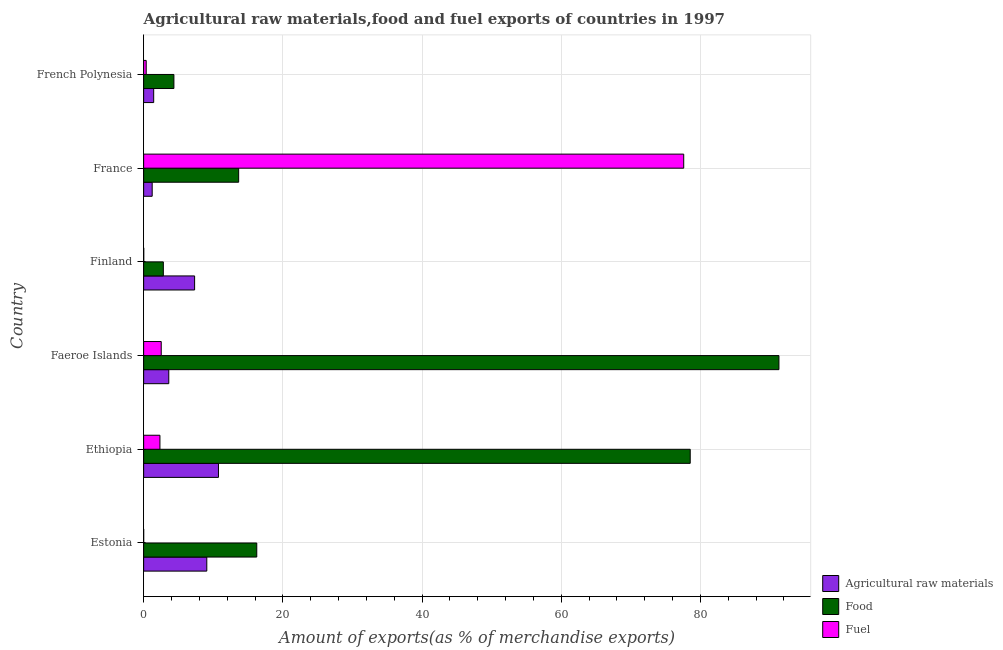How many groups of bars are there?
Provide a succinct answer. 6. Are the number of bars per tick equal to the number of legend labels?
Your answer should be compact. Yes. How many bars are there on the 1st tick from the top?
Ensure brevity in your answer.  3. What is the label of the 1st group of bars from the top?
Your answer should be compact. French Polynesia. What is the percentage of raw materials exports in Estonia?
Keep it short and to the point. 9.07. Across all countries, what is the maximum percentage of fuel exports?
Your response must be concise. 77.6. Across all countries, what is the minimum percentage of food exports?
Give a very brief answer. 2.83. In which country was the percentage of food exports maximum?
Make the answer very short. Faeroe Islands. In which country was the percentage of fuel exports minimum?
Provide a succinct answer. Estonia. What is the total percentage of food exports in the graph?
Keep it short and to the point. 206.9. What is the difference between the percentage of raw materials exports in Estonia and that in Faeroe Islands?
Your answer should be compact. 5.46. What is the difference between the percentage of raw materials exports in Ethiopia and the percentage of food exports in French Polynesia?
Keep it short and to the point. 6.4. What is the average percentage of fuel exports per country?
Your response must be concise. 13.81. What is the difference between the percentage of fuel exports and percentage of food exports in Faeroe Islands?
Offer a very short reply. -88.75. Is the percentage of raw materials exports in Faeroe Islands less than that in Finland?
Keep it short and to the point. Yes. What is the difference between the highest and the second highest percentage of fuel exports?
Offer a terse response. 75.08. What is the difference between the highest and the lowest percentage of raw materials exports?
Ensure brevity in your answer.  9.52. In how many countries, is the percentage of fuel exports greater than the average percentage of fuel exports taken over all countries?
Provide a succinct answer. 1. What does the 3rd bar from the top in France represents?
Your response must be concise. Agricultural raw materials. What does the 3rd bar from the bottom in Ethiopia represents?
Give a very brief answer. Fuel. How many bars are there?
Offer a very short reply. 18. Are all the bars in the graph horizontal?
Provide a succinct answer. Yes. Are the values on the major ticks of X-axis written in scientific E-notation?
Make the answer very short. No. Does the graph contain any zero values?
Keep it short and to the point. No. Where does the legend appear in the graph?
Provide a short and direct response. Bottom right. How many legend labels are there?
Your answer should be very brief. 3. How are the legend labels stacked?
Offer a very short reply. Vertical. What is the title of the graph?
Offer a terse response. Agricultural raw materials,food and fuel exports of countries in 1997. What is the label or title of the X-axis?
Your answer should be very brief. Amount of exports(as % of merchandise exports). What is the label or title of the Y-axis?
Provide a short and direct response. Country. What is the Amount of exports(as % of merchandise exports) of Agricultural raw materials in Estonia?
Provide a succinct answer. 9.07. What is the Amount of exports(as % of merchandise exports) of Food in Estonia?
Give a very brief answer. 16.25. What is the Amount of exports(as % of merchandise exports) in Fuel in Estonia?
Your answer should be very brief. 0. What is the Amount of exports(as % of merchandise exports) in Agricultural raw materials in Ethiopia?
Your answer should be very brief. 10.75. What is the Amount of exports(as % of merchandise exports) of Food in Ethiopia?
Make the answer very short. 78.54. What is the Amount of exports(as % of merchandise exports) of Fuel in Ethiopia?
Ensure brevity in your answer.  2.34. What is the Amount of exports(as % of merchandise exports) of Agricultural raw materials in Faeroe Islands?
Make the answer very short. 3.61. What is the Amount of exports(as % of merchandise exports) in Food in Faeroe Islands?
Keep it short and to the point. 91.28. What is the Amount of exports(as % of merchandise exports) of Fuel in Faeroe Islands?
Your answer should be very brief. 2.53. What is the Amount of exports(as % of merchandise exports) in Agricultural raw materials in Finland?
Provide a succinct answer. 7.32. What is the Amount of exports(as % of merchandise exports) in Food in Finland?
Your answer should be very brief. 2.83. What is the Amount of exports(as % of merchandise exports) in Fuel in Finland?
Give a very brief answer. 0.01. What is the Amount of exports(as % of merchandise exports) of Agricultural raw materials in France?
Offer a very short reply. 1.23. What is the Amount of exports(as % of merchandise exports) of Food in France?
Offer a terse response. 13.65. What is the Amount of exports(as % of merchandise exports) in Fuel in France?
Your answer should be compact. 77.6. What is the Amount of exports(as % of merchandise exports) of Agricultural raw materials in French Polynesia?
Provide a succinct answer. 1.44. What is the Amount of exports(as % of merchandise exports) of Food in French Polynesia?
Give a very brief answer. 4.35. What is the Amount of exports(as % of merchandise exports) of Fuel in French Polynesia?
Ensure brevity in your answer.  0.37. Across all countries, what is the maximum Amount of exports(as % of merchandise exports) of Agricultural raw materials?
Your response must be concise. 10.75. Across all countries, what is the maximum Amount of exports(as % of merchandise exports) in Food?
Your answer should be compact. 91.28. Across all countries, what is the maximum Amount of exports(as % of merchandise exports) in Fuel?
Provide a succinct answer. 77.6. Across all countries, what is the minimum Amount of exports(as % of merchandise exports) in Agricultural raw materials?
Give a very brief answer. 1.23. Across all countries, what is the minimum Amount of exports(as % of merchandise exports) of Food?
Offer a terse response. 2.83. Across all countries, what is the minimum Amount of exports(as % of merchandise exports) in Fuel?
Provide a succinct answer. 0. What is the total Amount of exports(as % of merchandise exports) of Agricultural raw materials in the graph?
Make the answer very short. 33.43. What is the total Amount of exports(as % of merchandise exports) in Food in the graph?
Your response must be concise. 206.9. What is the total Amount of exports(as % of merchandise exports) in Fuel in the graph?
Your response must be concise. 82.85. What is the difference between the Amount of exports(as % of merchandise exports) of Agricultural raw materials in Estonia and that in Ethiopia?
Your answer should be very brief. -1.68. What is the difference between the Amount of exports(as % of merchandise exports) in Food in Estonia and that in Ethiopia?
Provide a succinct answer. -62.28. What is the difference between the Amount of exports(as % of merchandise exports) in Fuel in Estonia and that in Ethiopia?
Give a very brief answer. -2.34. What is the difference between the Amount of exports(as % of merchandise exports) in Agricultural raw materials in Estonia and that in Faeroe Islands?
Offer a terse response. 5.46. What is the difference between the Amount of exports(as % of merchandise exports) in Food in Estonia and that in Faeroe Islands?
Keep it short and to the point. -75.03. What is the difference between the Amount of exports(as % of merchandise exports) in Fuel in Estonia and that in Faeroe Islands?
Your answer should be very brief. -2.53. What is the difference between the Amount of exports(as % of merchandise exports) in Agricultural raw materials in Estonia and that in Finland?
Provide a short and direct response. 1.75. What is the difference between the Amount of exports(as % of merchandise exports) of Food in Estonia and that in Finland?
Provide a succinct answer. 13.42. What is the difference between the Amount of exports(as % of merchandise exports) of Fuel in Estonia and that in Finland?
Make the answer very short. -0.01. What is the difference between the Amount of exports(as % of merchandise exports) of Agricultural raw materials in Estonia and that in France?
Your answer should be compact. 7.85. What is the difference between the Amount of exports(as % of merchandise exports) of Food in Estonia and that in France?
Make the answer very short. 2.6. What is the difference between the Amount of exports(as % of merchandise exports) in Fuel in Estonia and that in France?
Make the answer very short. -77.6. What is the difference between the Amount of exports(as % of merchandise exports) in Agricultural raw materials in Estonia and that in French Polynesia?
Your response must be concise. 7.63. What is the difference between the Amount of exports(as % of merchandise exports) in Food in Estonia and that in French Polynesia?
Keep it short and to the point. 11.91. What is the difference between the Amount of exports(as % of merchandise exports) in Fuel in Estonia and that in French Polynesia?
Your response must be concise. -0.37. What is the difference between the Amount of exports(as % of merchandise exports) in Agricultural raw materials in Ethiopia and that in Faeroe Islands?
Offer a terse response. 7.14. What is the difference between the Amount of exports(as % of merchandise exports) of Food in Ethiopia and that in Faeroe Islands?
Give a very brief answer. -12.75. What is the difference between the Amount of exports(as % of merchandise exports) in Fuel in Ethiopia and that in Faeroe Islands?
Make the answer very short. -0.19. What is the difference between the Amount of exports(as % of merchandise exports) in Agricultural raw materials in Ethiopia and that in Finland?
Make the answer very short. 3.43. What is the difference between the Amount of exports(as % of merchandise exports) in Food in Ethiopia and that in Finland?
Your answer should be very brief. 75.71. What is the difference between the Amount of exports(as % of merchandise exports) of Fuel in Ethiopia and that in Finland?
Your answer should be very brief. 2.33. What is the difference between the Amount of exports(as % of merchandise exports) of Agricultural raw materials in Ethiopia and that in France?
Offer a terse response. 9.52. What is the difference between the Amount of exports(as % of merchandise exports) of Food in Ethiopia and that in France?
Provide a short and direct response. 64.89. What is the difference between the Amount of exports(as % of merchandise exports) in Fuel in Ethiopia and that in France?
Your response must be concise. -75.26. What is the difference between the Amount of exports(as % of merchandise exports) of Agricultural raw materials in Ethiopia and that in French Polynesia?
Your answer should be very brief. 9.31. What is the difference between the Amount of exports(as % of merchandise exports) in Food in Ethiopia and that in French Polynesia?
Offer a very short reply. 74.19. What is the difference between the Amount of exports(as % of merchandise exports) of Fuel in Ethiopia and that in French Polynesia?
Make the answer very short. 1.97. What is the difference between the Amount of exports(as % of merchandise exports) in Agricultural raw materials in Faeroe Islands and that in Finland?
Your answer should be very brief. -3.71. What is the difference between the Amount of exports(as % of merchandise exports) of Food in Faeroe Islands and that in Finland?
Make the answer very short. 88.45. What is the difference between the Amount of exports(as % of merchandise exports) in Fuel in Faeroe Islands and that in Finland?
Make the answer very short. 2.51. What is the difference between the Amount of exports(as % of merchandise exports) of Agricultural raw materials in Faeroe Islands and that in France?
Your answer should be very brief. 2.39. What is the difference between the Amount of exports(as % of merchandise exports) of Food in Faeroe Islands and that in France?
Your answer should be very brief. 77.63. What is the difference between the Amount of exports(as % of merchandise exports) in Fuel in Faeroe Islands and that in France?
Make the answer very short. -75.07. What is the difference between the Amount of exports(as % of merchandise exports) in Agricultural raw materials in Faeroe Islands and that in French Polynesia?
Your answer should be very brief. 2.17. What is the difference between the Amount of exports(as % of merchandise exports) in Food in Faeroe Islands and that in French Polynesia?
Offer a very short reply. 86.93. What is the difference between the Amount of exports(as % of merchandise exports) in Fuel in Faeroe Islands and that in French Polynesia?
Keep it short and to the point. 2.16. What is the difference between the Amount of exports(as % of merchandise exports) in Agricultural raw materials in Finland and that in France?
Ensure brevity in your answer.  6.1. What is the difference between the Amount of exports(as % of merchandise exports) in Food in Finland and that in France?
Offer a very short reply. -10.82. What is the difference between the Amount of exports(as % of merchandise exports) in Fuel in Finland and that in France?
Offer a very short reply. -77.59. What is the difference between the Amount of exports(as % of merchandise exports) in Agricultural raw materials in Finland and that in French Polynesia?
Your response must be concise. 5.88. What is the difference between the Amount of exports(as % of merchandise exports) of Food in Finland and that in French Polynesia?
Your answer should be very brief. -1.52. What is the difference between the Amount of exports(as % of merchandise exports) in Fuel in Finland and that in French Polynesia?
Offer a very short reply. -0.35. What is the difference between the Amount of exports(as % of merchandise exports) of Agricultural raw materials in France and that in French Polynesia?
Ensure brevity in your answer.  -0.22. What is the difference between the Amount of exports(as % of merchandise exports) in Food in France and that in French Polynesia?
Make the answer very short. 9.3. What is the difference between the Amount of exports(as % of merchandise exports) in Fuel in France and that in French Polynesia?
Provide a succinct answer. 77.23. What is the difference between the Amount of exports(as % of merchandise exports) of Agricultural raw materials in Estonia and the Amount of exports(as % of merchandise exports) of Food in Ethiopia?
Provide a succinct answer. -69.46. What is the difference between the Amount of exports(as % of merchandise exports) of Agricultural raw materials in Estonia and the Amount of exports(as % of merchandise exports) of Fuel in Ethiopia?
Make the answer very short. 6.73. What is the difference between the Amount of exports(as % of merchandise exports) in Food in Estonia and the Amount of exports(as % of merchandise exports) in Fuel in Ethiopia?
Offer a terse response. 13.91. What is the difference between the Amount of exports(as % of merchandise exports) of Agricultural raw materials in Estonia and the Amount of exports(as % of merchandise exports) of Food in Faeroe Islands?
Your response must be concise. -82.21. What is the difference between the Amount of exports(as % of merchandise exports) of Agricultural raw materials in Estonia and the Amount of exports(as % of merchandise exports) of Fuel in Faeroe Islands?
Offer a very short reply. 6.55. What is the difference between the Amount of exports(as % of merchandise exports) of Food in Estonia and the Amount of exports(as % of merchandise exports) of Fuel in Faeroe Islands?
Keep it short and to the point. 13.73. What is the difference between the Amount of exports(as % of merchandise exports) of Agricultural raw materials in Estonia and the Amount of exports(as % of merchandise exports) of Food in Finland?
Your answer should be very brief. 6.24. What is the difference between the Amount of exports(as % of merchandise exports) in Agricultural raw materials in Estonia and the Amount of exports(as % of merchandise exports) in Fuel in Finland?
Provide a succinct answer. 9.06. What is the difference between the Amount of exports(as % of merchandise exports) in Food in Estonia and the Amount of exports(as % of merchandise exports) in Fuel in Finland?
Ensure brevity in your answer.  16.24. What is the difference between the Amount of exports(as % of merchandise exports) in Agricultural raw materials in Estonia and the Amount of exports(as % of merchandise exports) in Food in France?
Offer a terse response. -4.58. What is the difference between the Amount of exports(as % of merchandise exports) of Agricultural raw materials in Estonia and the Amount of exports(as % of merchandise exports) of Fuel in France?
Provide a succinct answer. -68.53. What is the difference between the Amount of exports(as % of merchandise exports) in Food in Estonia and the Amount of exports(as % of merchandise exports) in Fuel in France?
Give a very brief answer. -61.35. What is the difference between the Amount of exports(as % of merchandise exports) in Agricultural raw materials in Estonia and the Amount of exports(as % of merchandise exports) in Food in French Polynesia?
Your answer should be very brief. 4.72. What is the difference between the Amount of exports(as % of merchandise exports) in Agricultural raw materials in Estonia and the Amount of exports(as % of merchandise exports) in Fuel in French Polynesia?
Provide a succinct answer. 8.71. What is the difference between the Amount of exports(as % of merchandise exports) in Food in Estonia and the Amount of exports(as % of merchandise exports) in Fuel in French Polynesia?
Your response must be concise. 15.89. What is the difference between the Amount of exports(as % of merchandise exports) in Agricultural raw materials in Ethiopia and the Amount of exports(as % of merchandise exports) in Food in Faeroe Islands?
Ensure brevity in your answer.  -80.53. What is the difference between the Amount of exports(as % of merchandise exports) of Agricultural raw materials in Ethiopia and the Amount of exports(as % of merchandise exports) of Fuel in Faeroe Islands?
Provide a succinct answer. 8.22. What is the difference between the Amount of exports(as % of merchandise exports) of Food in Ethiopia and the Amount of exports(as % of merchandise exports) of Fuel in Faeroe Islands?
Your answer should be compact. 76.01. What is the difference between the Amount of exports(as % of merchandise exports) in Agricultural raw materials in Ethiopia and the Amount of exports(as % of merchandise exports) in Food in Finland?
Ensure brevity in your answer.  7.92. What is the difference between the Amount of exports(as % of merchandise exports) in Agricultural raw materials in Ethiopia and the Amount of exports(as % of merchandise exports) in Fuel in Finland?
Keep it short and to the point. 10.74. What is the difference between the Amount of exports(as % of merchandise exports) in Food in Ethiopia and the Amount of exports(as % of merchandise exports) in Fuel in Finland?
Keep it short and to the point. 78.52. What is the difference between the Amount of exports(as % of merchandise exports) of Agricultural raw materials in Ethiopia and the Amount of exports(as % of merchandise exports) of Food in France?
Your answer should be compact. -2.9. What is the difference between the Amount of exports(as % of merchandise exports) in Agricultural raw materials in Ethiopia and the Amount of exports(as % of merchandise exports) in Fuel in France?
Your answer should be very brief. -66.85. What is the difference between the Amount of exports(as % of merchandise exports) of Food in Ethiopia and the Amount of exports(as % of merchandise exports) of Fuel in France?
Your response must be concise. 0.93. What is the difference between the Amount of exports(as % of merchandise exports) in Agricultural raw materials in Ethiopia and the Amount of exports(as % of merchandise exports) in Food in French Polynesia?
Give a very brief answer. 6.4. What is the difference between the Amount of exports(as % of merchandise exports) of Agricultural raw materials in Ethiopia and the Amount of exports(as % of merchandise exports) of Fuel in French Polynesia?
Keep it short and to the point. 10.38. What is the difference between the Amount of exports(as % of merchandise exports) in Food in Ethiopia and the Amount of exports(as % of merchandise exports) in Fuel in French Polynesia?
Offer a very short reply. 78.17. What is the difference between the Amount of exports(as % of merchandise exports) in Agricultural raw materials in Faeroe Islands and the Amount of exports(as % of merchandise exports) in Food in Finland?
Offer a very short reply. 0.78. What is the difference between the Amount of exports(as % of merchandise exports) in Agricultural raw materials in Faeroe Islands and the Amount of exports(as % of merchandise exports) in Fuel in Finland?
Ensure brevity in your answer.  3.6. What is the difference between the Amount of exports(as % of merchandise exports) of Food in Faeroe Islands and the Amount of exports(as % of merchandise exports) of Fuel in Finland?
Your answer should be compact. 91.27. What is the difference between the Amount of exports(as % of merchandise exports) of Agricultural raw materials in Faeroe Islands and the Amount of exports(as % of merchandise exports) of Food in France?
Offer a very short reply. -10.04. What is the difference between the Amount of exports(as % of merchandise exports) in Agricultural raw materials in Faeroe Islands and the Amount of exports(as % of merchandise exports) in Fuel in France?
Keep it short and to the point. -73.99. What is the difference between the Amount of exports(as % of merchandise exports) in Food in Faeroe Islands and the Amount of exports(as % of merchandise exports) in Fuel in France?
Offer a terse response. 13.68. What is the difference between the Amount of exports(as % of merchandise exports) of Agricultural raw materials in Faeroe Islands and the Amount of exports(as % of merchandise exports) of Food in French Polynesia?
Offer a very short reply. -0.74. What is the difference between the Amount of exports(as % of merchandise exports) of Agricultural raw materials in Faeroe Islands and the Amount of exports(as % of merchandise exports) of Fuel in French Polynesia?
Keep it short and to the point. 3.24. What is the difference between the Amount of exports(as % of merchandise exports) of Food in Faeroe Islands and the Amount of exports(as % of merchandise exports) of Fuel in French Polynesia?
Offer a very short reply. 90.92. What is the difference between the Amount of exports(as % of merchandise exports) of Agricultural raw materials in Finland and the Amount of exports(as % of merchandise exports) of Food in France?
Provide a succinct answer. -6.33. What is the difference between the Amount of exports(as % of merchandise exports) of Agricultural raw materials in Finland and the Amount of exports(as % of merchandise exports) of Fuel in France?
Provide a succinct answer. -70.28. What is the difference between the Amount of exports(as % of merchandise exports) in Food in Finland and the Amount of exports(as % of merchandise exports) in Fuel in France?
Provide a short and direct response. -74.77. What is the difference between the Amount of exports(as % of merchandise exports) of Agricultural raw materials in Finland and the Amount of exports(as % of merchandise exports) of Food in French Polynesia?
Offer a very short reply. 2.97. What is the difference between the Amount of exports(as % of merchandise exports) of Agricultural raw materials in Finland and the Amount of exports(as % of merchandise exports) of Fuel in French Polynesia?
Provide a short and direct response. 6.96. What is the difference between the Amount of exports(as % of merchandise exports) in Food in Finland and the Amount of exports(as % of merchandise exports) in Fuel in French Polynesia?
Your response must be concise. 2.46. What is the difference between the Amount of exports(as % of merchandise exports) in Agricultural raw materials in France and the Amount of exports(as % of merchandise exports) in Food in French Polynesia?
Make the answer very short. -3.12. What is the difference between the Amount of exports(as % of merchandise exports) of Agricultural raw materials in France and the Amount of exports(as % of merchandise exports) of Fuel in French Polynesia?
Your response must be concise. 0.86. What is the difference between the Amount of exports(as % of merchandise exports) in Food in France and the Amount of exports(as % of merchandise exports) in Fuel in French Polynesia?
Give a very brief answer. 13.28. What is the average Amount of exports(as % of merchandise exports) of Agricultural raw materials per country?
Ensure brevity in your answer.  5.57. What is the average Amount of exports(as % of merchandise exports) in Food per country?
Give a very brief answer. 34.48. What is the average Amount of exports(as % of merchandise exports) of Fuel per country?
Provide a short and direct response. 13.81. What is the difference between the Amount of exports(as % of merchandise exports) in Agricultural raw materials and Amount of exports(as % of merchandise exports) in Food in Estonia?
Provide a short and direct response. -7.18. What is the difference between the Amount of exports(as % of merchandise exports) in Agricultural raw materials and Amount of exports(as % of merchandise exports) in Fuel in Estonia?
Provide a short and direct response. 9.07. What is the difference between the Amount of exports(as % of merchandise exports) in Food and Amount of exports(as % of merchandise exports) in Fuel in Estonia?
Provide a short and direct response. 16.25. What is the difference between the Amount of exports(as % of merchandise exports) of Agricultural raw materials and Amount of exports(as % of merchandise exports) of Food in Ethiopia?
Ensure brevity in your answer.  -67.78. What is the difference between the Amount of exports(as % of merchandise exports) of Agricultural raw materials and Amount of exports(as % of merchandise exports) of Fuel in Ethiopia?
Give a very brief answer. 8.41. What is the difference between the Amount of exports(as % of merchandise exports) of Food and Amount of exports(as % of merchandise exports) of Fuel in Ethiopia?
Make the answer very short. 76.2. What is the difference between the Amount of exports(as % of merchandise exports) in Agricultural raw materials and Amount of exports(as % of merchandise exports) in Food in Faeroe Islands?
Keep it short and to the point. -87.67. What is the difference between the Amount of exports(as % of merchandise exports) in Agricultural raw materials and Amount of exports(as % of merchandise exports) in Fuel in Faeroe Islands?
Keep it short and to the point. 1.08. What is the difference between the Amount of exports(as % of merchandise exports) of Food and Amount of exports(as % of merchandise exports) of Fuel in Faeroe Islands?
Make the answer very short. 88.76. What is the difference between the Amount of exports(as % of merchandise exports) of Agricultural raw materials and Amount of exports(as % of merchandise exports) of Food in Finland?
Your answer should be compact. 4.49. What is the difference between the Amount of exports(as % of merchandise exports) of Agricultural raw materials and Amount of exports(as % of merchandise exports) of Fuel in Finland?
Your answer should be compact. 7.31. What is the difference between the Amount of exports(as % of merchandise exports) in Food and Amount of exports(as % of merchandise exports) in Fuel in Finland?
Offer a very short reply. 2.82. What is the difference between the Amount of exports(as % of merchandise exports) of Agricultural raw materials and Amount of exports(as % of merchandise exports) of Food in France?
Make the answer very short. -12.42. What is the difference between the Amount of exports(as % of merchandise exports) in Agricultural raw materials and Amount of exports(as % of merchandise exports) in Fuel in France?
Offer a terse response. -76.38. What is the difference between the Amount of exports(as % of merchandise exports) of Food and Amount of exports(as % of merchandise exports) of Fuel in France?
Your answer should be compact. -63.95. What is the difference between the Amount of exports(as % of merchandise exports) of Agricultural raw materials and Amount of exports(as % of merchandise exports) of Food in French Polynesia?
Ensure brevity in your answer.  -2.91. What is the difference between the Amount of exports(as % of merchandise exports) in Agricultural raw materials and Amount of exports(as % of merchandise exports) in Fuel in French Polynesia?
Give a very brief answer. 1.07. What is the difference between the Amount of exports(as % of merchandise exports) in Food and Amount of exports(as % of merchandise exports) in Fuel in French Polynesia?
Your answer should be compact. 3.98. What is the ratio of the Amount of exports(as % of merchandise exports) of Agricultural raw materials in Estonia to that in Ethiopia?
Your answer should be very brief. 0.84. What is the ratio of the Amount of exports(as % of merchandise exports) of Food in Estonia to that in Ethiopia?
Your answer should be very brief. 0.21. What is the ratio of the Amount of exports(as % of merchandise exports) of Agricultural raw materials in Estonia to that in Faeroe Islands?
Your response must be concise. 2.51. What is the ratio of the Amount of exports(as % of merchandise exports) of Food in Estonia to that in Faeroe Islands?
Your response must be concise. 0.18. What is the ratio of the Amount of exports(as % of merchandise exports) in Agricultural raw materials in Estonia to that in Finland?
Your answer should be very brief. 1.24. What is the ratio of the Amount of exports(as % of merchandise exports) in Food in Estonia to that in Finland?
Offer a terse response. 5.74. What is the ratio of the Amount of exports(as % of merchandise exports) of Fuel in Estonia to that in Finland?
Give a very brief answer. 0.08. What is the ratio of the Amount of exports(as % of merchandise exports) in Agricultural raw materials in Estonia to that in France?
Offer a very short reply. 7.39. What is the ratio of the Amount of exports(as % of merchandise exports) of Food in Estonia to that in France?
Provide a short and direct response. 1.19. What is the ratio of the Amount of exports(as % of merchandise exports) in Agricultural raw materials in Estonia to that in French Polynesia?
Your response must be concise. 6.29. What is the ratio of the Amount of exports(as % of merchandise exports) in Food in Estonia to that in French Polynesia?
Offer a very short reply. 3.74. What is the ratio of the Amount of exports(as % of merchandise exports) in Fuel in Estonia to that in French Polynesia?
Your response must be concise. 0. What is the ratio of the Amount of exports(as % of merchandise exports) in Agricultural raw materials in Ethiopia to that in Faeroe Islands?
Give a very brief answer. 2.98. What is the ratio of the Amount of exports(as % of merchandise exports) in Food in Ethiopia to that in Faeroe Islands?
Your response must be concise. 0.86. What is the ratio of the Amount of exports(as % of merchandise exports) in Fuel in Ethiopia to that in Faeroe Islands?
Keep it short and to the point. 0.93. What is the ratio of the Amount of exports(as % of merchandise exports) in Agricultural raw materials in Ethiopia to that in Finland?
Your response must be concise. 1.47. What is the ratio of the Amount of exports(as % of merchandise exports) in Food in Ethiopia to that in Finland?
Make the answer very short. 27.74. What is the ratio of the Amount of exports(as % of merchandise exports) of Fuel in Ethiopia to that in Finland?
Your answer should be very brief. 177.94. What is the ratio of the Amount of exports(as % of merchandise exports) of Agricultural raw materials in Ethiopia to that in France?
Your answer should be very brief. 8.76. What is the ratio of the Amount of exports(as % of merchandise exports) of Food in Ethiopia to that in France?
Offer a very short reply. 5.75. What is the ratio of the Amount of exports(as % of merchandise exports) in Fuel in Ethiopia to that in France?
Your response must be concise. 0.03. What is the ratio of the Amount of exports(as % of merchandise exports) in Agricultural raw materials in Ethiopia to that in French Polynesia?
Your answer should be very brief. 7.46. What is the ratio of the Amount of exports(as % of merchandise exports) of Food in Ethiopia to that in French Polynesia?
Offer a very short reply. 18.06. What is the ratio of the Amount of exports(as % of merchandise exports) in Fuel in Ethiopia to that in French Polynesia?
Give a very brief answer. 6.37. What is the ratio of the Amount of exports(as % of merchandise exports) of Agricultural raw materials in Faeroe Islands to that in Finland?
Ensure brevity in your answer.  0.49. What is the ratio of the Amount of exports(as % of merchandise exports) of Food in Faeroe Islands to that in Finland?
Ensure brevity in your answer.  32.25. What is the ratio of the Amount of exports(as % of merchandise exports) in Fuel in Faeroe Islands to that in Finland?
Provide a succinct answer. 192.18. What is the ratio of the Amount of exports(as % of merchandise exports) in Agricultural raw materials in Faeroe Islands to that in France?
Your answer should be compact. 2.94. What is the ratio of the Amount of exports(as % of merchandise exports) of Food in Faeroe Islands to that in France?
Keep it short and to the point. 6.69. What is the ratio of the Amount of exports(as % of merchandise exports) of Fuel in Faeroe Islands to that in France?
Offer a very short reply. 0.03. What is the ratio of the Amount of exports(as % of merchandise exports) in Agricultural raw materials in Faeroe Islands to that in French Polynesia?
Your answer should be very brief. 2.5. What is the ratio of the Amount of exports(as % of merchandise exports) of Food in Faeroe Islands to that in French Polynesia?
Your answer should be compact. 20.99. What is the ratio of the Amount of exports(as % of merchandise exports) of Fuel in Faeroe Islands to that in French Polynesia?
Give a very brief answer. 6.88. What is the ratio of the Amount of exports(as % of merchandise exports) in Agricultural raw materials in Finland to that in France?
Provide a succinct answer. 5.97. What is the ratio of the Amount of exports(as % of merchandise exports) in Food in Finland to that in France?
Provide a short and direct response. 0.21. What is the ratio of the Amount of exports(as % of merchandise exports) of Fuel in Finland to that in France?
Offer a terse response. 0. What is the ratio of the Amount of exports(as % of merchandise exports) of Agricultural raw materials in Finland to that in French Polynesia?
Ensure brevity in your answer.  5.08. What is the ratio of the Amount of exports(as % of merchandise exports) of Food in Finland to that in French Polynesia?
Give a very brief answer. 0.65. What is the ratio of the Amount of exports(as % of merchandise exports) in Fuel in Finland to that in French Polynesia?
Provide a short and direct response. 0.04. What is the ratio of the Amount of exports(as % of merchandise exports) in Agricultural raw materials in France to that in French Polynesia?
Keep it short and to the point. 0.85. What is the ratio of the Amount of exports(as % of merchandise exports) in Food in France to that in French Polynesia?
Provide a succinct answer. 3.14. What is the ratio of the Amount of exports(as % of merchandise exports) of Fuel in France to that in French Polynesia?
Your answer should be very brief. 211.28. What is the difference between the highest and the second highest Amount of exports(as % of merchandise exports) of Agricultural raw materials?
Provide a short and direct response. 1.68. What is the difference between the highest and the second highest Amount of exports(as % of merchandise exports) of Food?
Give a very brief answer. 12.75. What is the difference between the highest and the second highest Amount of exports(as % of merchandise exports) in Fuel?
Offer a very short reply. 75.07. What is the difference between the highest and the lowest Amount of exports(as % of merchandise exports) in Agricultural raw materials?
Your answer should be compact. 9.52. What is the difference between the highest and the lowest Amount of exports(as % of merchandise exports) in Food?
Your answer should be very brief. 88.45. What is the difference between the highest and the lowest Amount of exports(as % of merchandise exports) in Fuel?
Your response must be concise. 77.6. 